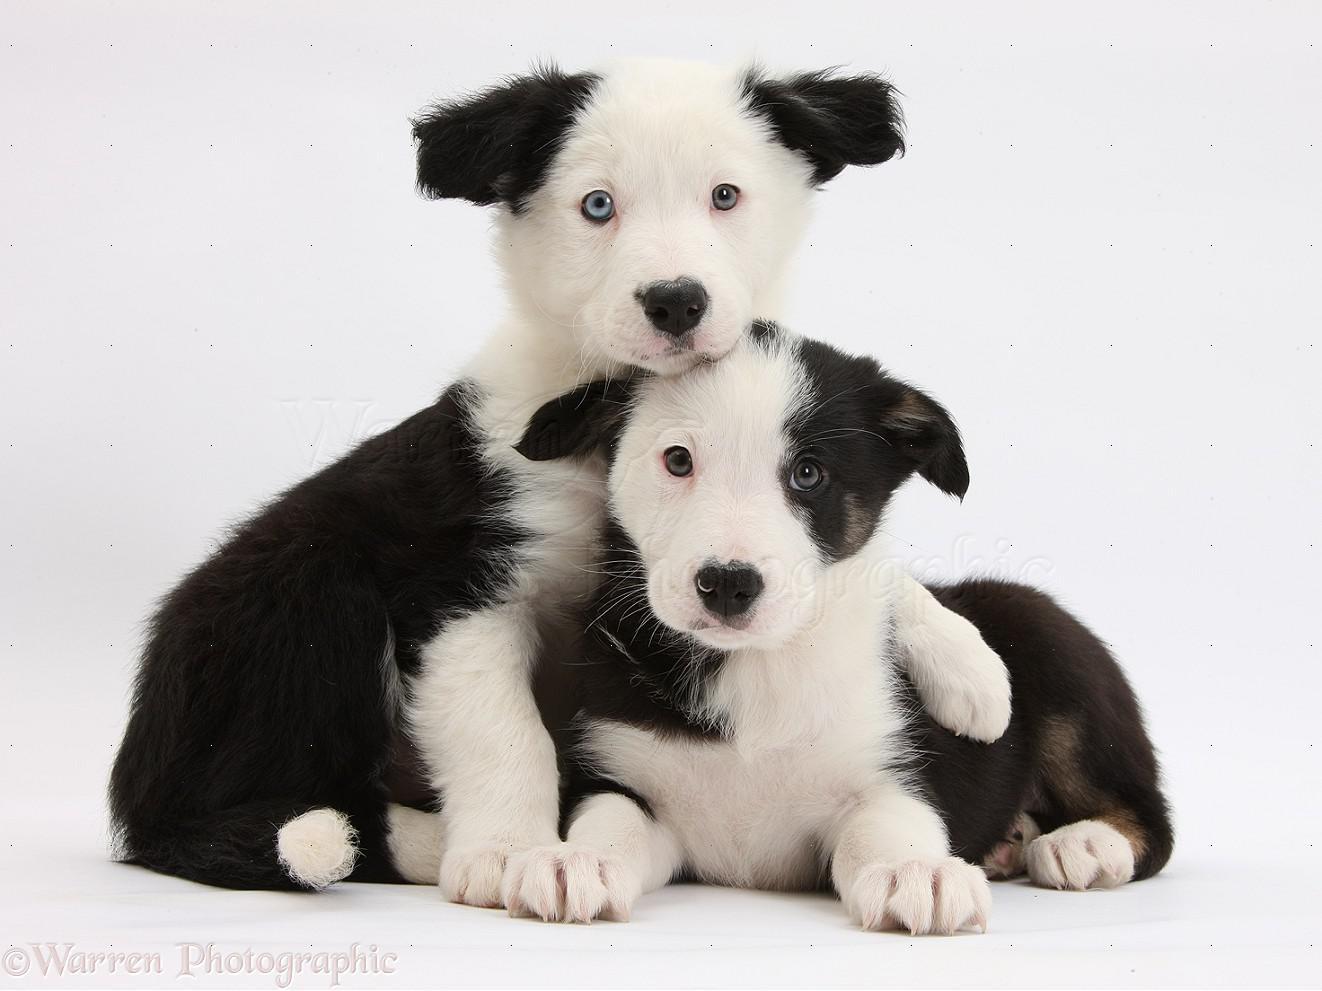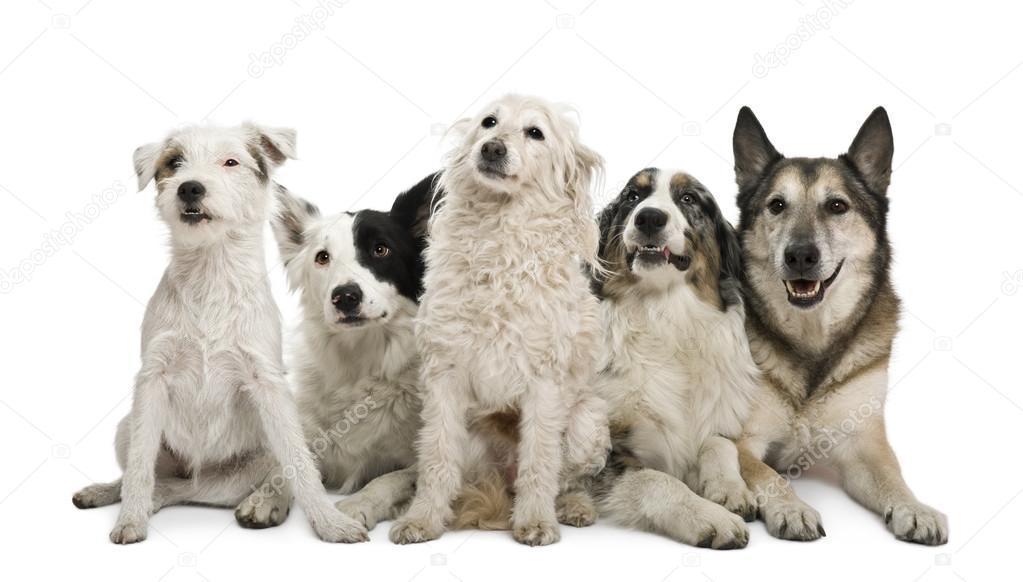The first image is the image on the left, the second image is the image on the right. Examine the images to the left and right. Is the description "The right image contains exactly two dogs." accurate? Answer yes or no. No. 